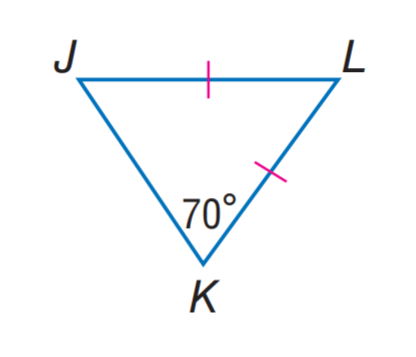Question: Find m \angle J L K.
Choices:
A. 30
B. 40
C. 50
D. 70
Answer with the letter. Answer: B 